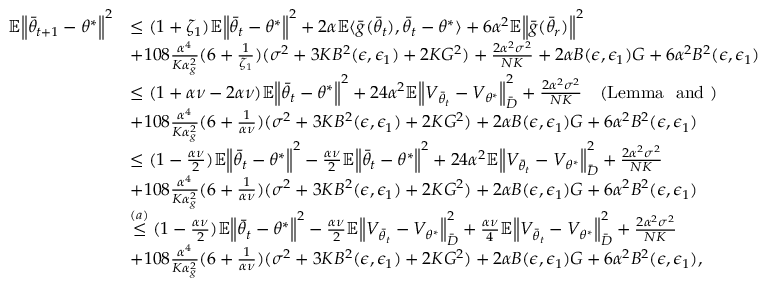Convert formula to latex. <formula><loc_0><loc_0><loc_500><loc_500>\begin{array} { r l } { \mathbb { E } \left \| \bar { \theta } _ { t + 1 } - \theta ^ { * } \right \| ^ { 2 } } & { \leq ( 1 + \zeta _ { 1 } ) \mathbb { E } \left \| \bar { \theta } _ { t } - \theta ^ { * } \right \| ^ { 2 } + 2 \alpha \mathbb { E } \langle \bar { g } ( \bar { \theta } _ { t } ) , \bar { \theta } _ { t } - \theta ^ { * } \rangle + 6 \alpha ^ { 2 } \mathbb { E } \left \| \bar { g } ( \bar { \theta } _ { r } ) \right \| ^ { 2 } } \\ & { + 1 0 8 \frac { \alpha ^ { 4 } } { K \alpha _ { g } ^ { 2 } } ( 6 + \frac { 1 } { \zeta _ { 1 } } ) ( \sigma ^ { 2 } + 3 K B ^ { 2 } ( \epsilon , \epsilon _ { 1 } ) + 2 K G ^ { 2 } ) + \frac { 2 \alpha ^ { 2 } \sigma ^ { 2 } } { N K } + 2 \alpha B ( \epsilon , \epsilon _ { 1 } ) G + 6 \alpha ^ { 2 } B ^ { 2 } ( \epsilon , \epsilon _ { 1 } ) } \\ & { \leq ( 1 + \alpha \nu - 2 \alpha \nu ) \mathbb { E } \left \| \bar { \theta } _ { t } - \theta ^ { * } \right \| ^ { 2 } + 2 4 \alpha ^ { 2 } \mathbb { E } \left \| V _ { \bar { \theta } _ { t } } - V _ { \theta ^ { * } } \right \| _ { \bar { D } } ^ { 2 } + \frac { 2 \alpha ^ { 2 } \sigma ^ { 2 } } { N K } \quad ( L e m m a a n d ) } \\ & { + 1 0 8 \frac { \alpha ^ { 4 } } { K \alpha _ { g } ^ { 2 } } ( 6 + \frac { 1 } { \alpha \nu } ) ( \sigma ^ { 2 } + 3 K B ^ { 2 } ( \epsilon , \epsilon _ { 1 } ) + 2 K G ^ { 2 } ) + 2 \alpha B ( \epsilon , \epsilon _ { 1 } ) G + 6 \alpha ^ { 2 } B ^ { 2 } ( \epsilon , \epsilon _ { 1 } ) } \\ & { \leq ( 1 - \frac { \alpha \nu } { 2 } ) \mathbb { E } \left \| \bar { \theta } _ { t } - \theta ^ { * } \right \| ^ { 2 } - \frac { \alpha \nu } { 2 } \mathbb { E } \left \| \bar { \theta } _ { t } - \theta ^ { * } \right \| ^ { 2 } + 2 4 \alpha ^ { 2 } \mathbb { E } \left \| V _ { \bar { \theta } _ { t } } - V _ { \theta ^ { * } } \right \| _ { \bar { D } } ^ { 2 } + \frac { 2 \alpha ^ { 2 } \sigma ^ { 2 } } { N K } } \\ & { + 1 0 8 \frac { \alpha ^ { 4 } } { K \alpha _ { g } ^ { 2 } } ( 6 + \frac { 1 } { \alpha \nu } ) ( \sigma ^ { 2 } + 3 K B ^ { 2 } ( \epsilon , \epsilon _ { 1 } ) + 2 K G ^ { 2 } ) + 2 \alpha B ( \epsilon , \epsilon _ { 1 } ) G + 6 \alpha ^ { 2 } B ^ { 2 } ( \epsilon , \epsilon _ { 1 } ) } \\ & { \stackrel { ( a ) } { \leq } ( 1 - \frac { \alpha \nu } { 2 } ) \mathbb { E } \left \| \bar { \theta } _ { t } - \theta ^ { * } \right \| ^ { 2 } - \frac { \alpha \nu } { 2 } \mathbb { E } \left \| V _ { \bar { \theta } _ { t } } - V _ { \theta ^ { * } } \right \| _ { \bar { D } } ^ { 2 } + \frac { \alpha \nu } { 4 } \mathbb { E } \left \| V _ { \bar { \theta } _ { t } } - V _ { \theta ^ { * } } \right \| _ { \bar { D } } ^ { 2 } + \frac { 2 \alpha ^ { 2 } \sigma ^ { 2 } } { N K } } \\ & { + 1 0 8 \frac { \alpha ^ { 4 } } { K \alpha _ { g } ^ { 2 } } ( 6 + \frac { 1 } { \alpha \nu } ) ( \sigma ^ { 2 } + 3 K B ^ { 2 } ( \epsilon , \epsilon _ { 1 } ) + 2 K G ^ { 2 } ) + 2 \alpha B ( \epsilon , \epsilon _ { 1 } ) G + 6 \alpha ^ { 2 } B ^ { 2 } ( \epsilon , \epsilon _ { 1 } ) , } \end{array}</formula> 